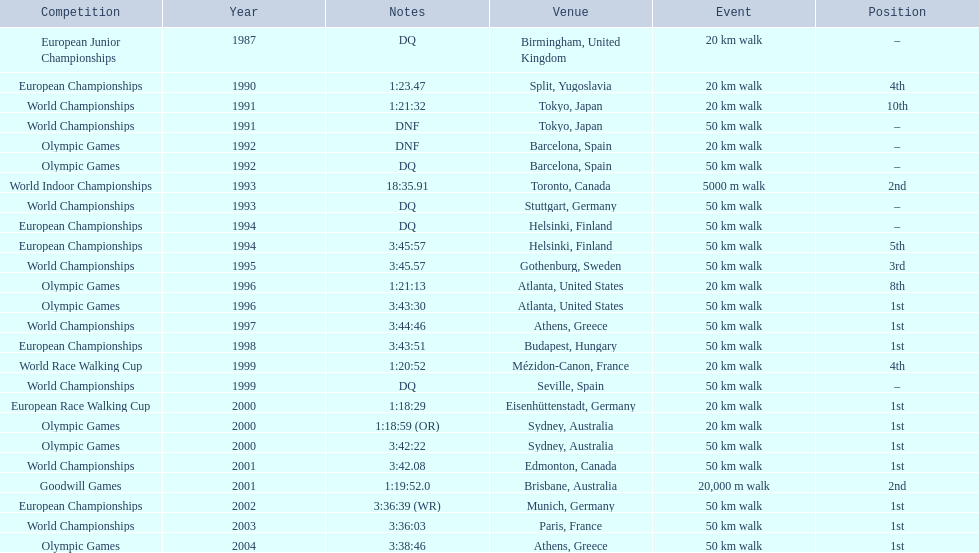In 1990 what position did robert korzeniowski place? 4th. In 1993 what was robert korzeniowski's place in the world indoor championships? 2nd. How long did the 50km walk in 2004 olympic cost? 3:38:46. 